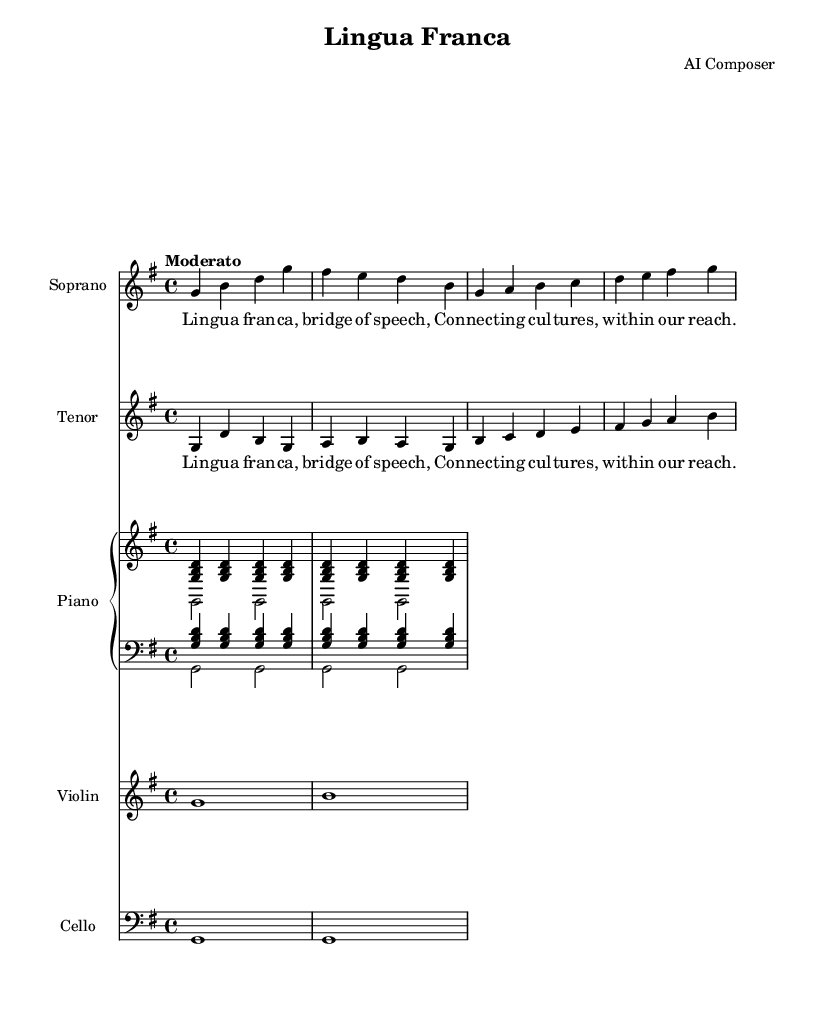What is the key signature of this music? The key signature is G major, which has one sharp (F#). This can be determined by looking at the key signature indicated at the beginning of the score.
Answer: G major What is the time signature of this music? The time signature is 4/4, which is represented as a fraction indicating four beats per measure in the music. This can be found near the beginning of the score.
Answer: 4/4 What is the tempo marking of this music? The tempo marking is "Moderato," which indicates a moderate pace. This can be found at the beginning of the score, right after the key and time signature.
Answer: Moderato How many measures are in the soprano part? The soprano part contains four measures, which can be counted by looking at the grouping of notes within the staff.
Answer: 4 Identify the instruments featured in this score. The featured instruments are Soprano, Tenor, Piano, Violin, and Cello. This information can be inferred from the staff names provided at the beginning of each instrument section.
Answer: Soprano, Tenor, Piano, Violin, Cello In which voice do the lyrics "Lingua Franca, bridge of speech" appear? The lyrics appear in both the Soprano and Tenor voices, as both parts use the same lyric text underneath their respective notes.
Answer: Soprano and Tenor What is the first note of the cello part? The first note of the cello part is G. This can be found by looking at the first note in the cello staff, which is notated as a single quarter note.
Answer: G 